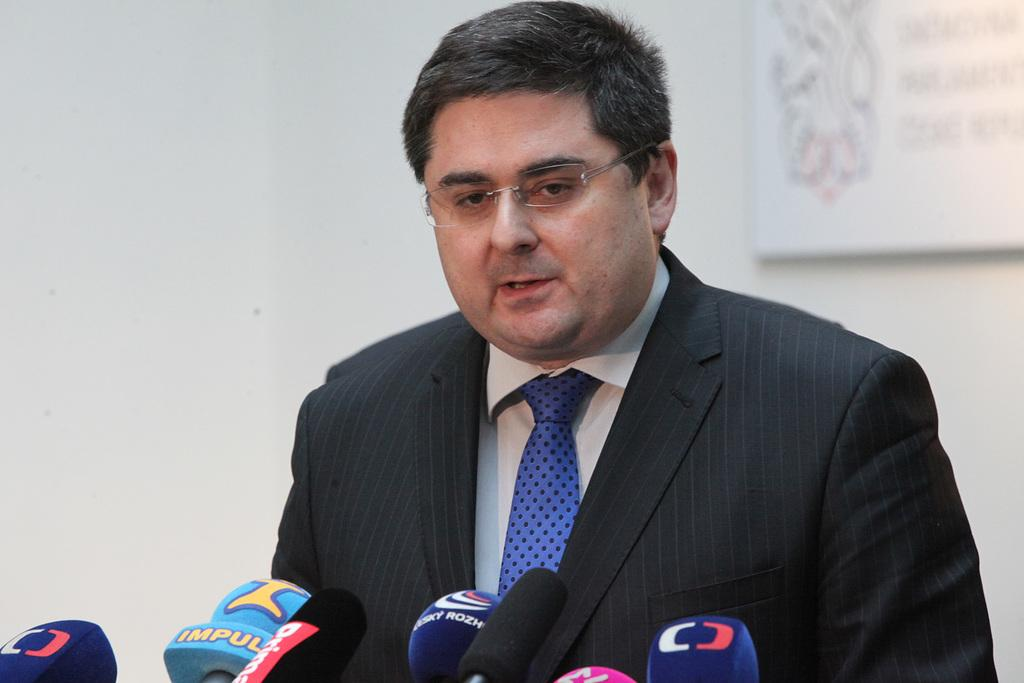Who or what is present in the image? There is a person in the image. Can you describe the person's appearance? The person is wearing spectacles. What objects can be seen in the image? There are microphones in the image. What is visible in the background of the image? There is a wall in the background of the image. What is located on the right side of the image? There is a frame on the right side of the image. What type of alley can be seen behind the person in the image? There is no alley visible in the image; it features a wall in the background. Can you tell me how many hens are present in the image? There are no hens present in the image. 